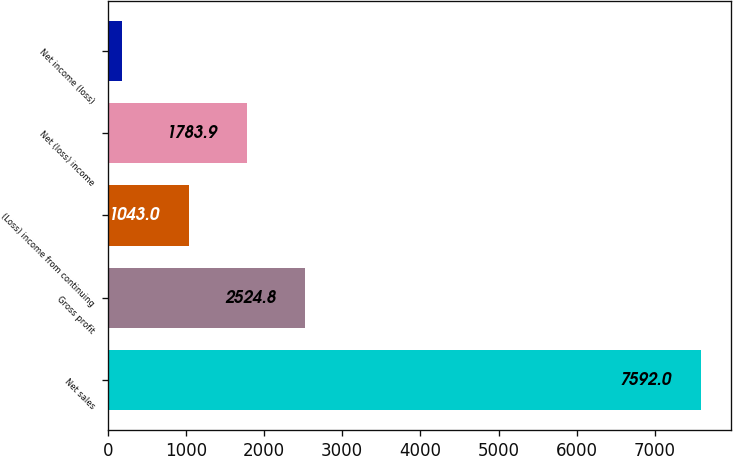<chart> <loc_0><loc_0><loc_500><loc_500><bar_chart><fcel>Net sales<fcel>Gross profit<fcel>(Loss) income from continuing<fcel>Net (loss) income<fcel>Net income (loss)<nl><fcel>7592<fcel>2524.8<fcel>1043<fcel>1783.9<fcel>183<nl></chart> 